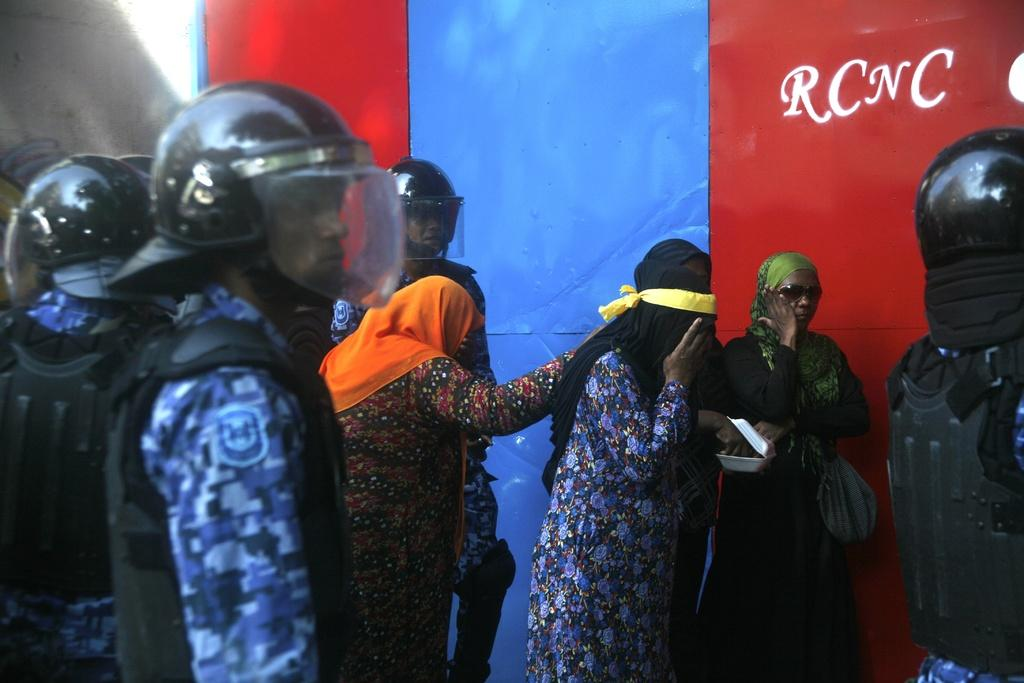How many people are in the group in the image? There is a group of persons in the image. What are the persons wearing on their heads? The persons are wearing helmets. Can you describe the appearance of one person in the group? One person in the group is wearing a scarf. What can be seen on the wall in the image? There is a colorful design on a wall in the image. What type of crime is being committed in the image? There is no indication of a crime being committed in the image. Can you tell me how many screws are visible in the image? There is no mention of screws in the image; the focus is on the group of persons and the wall design. 